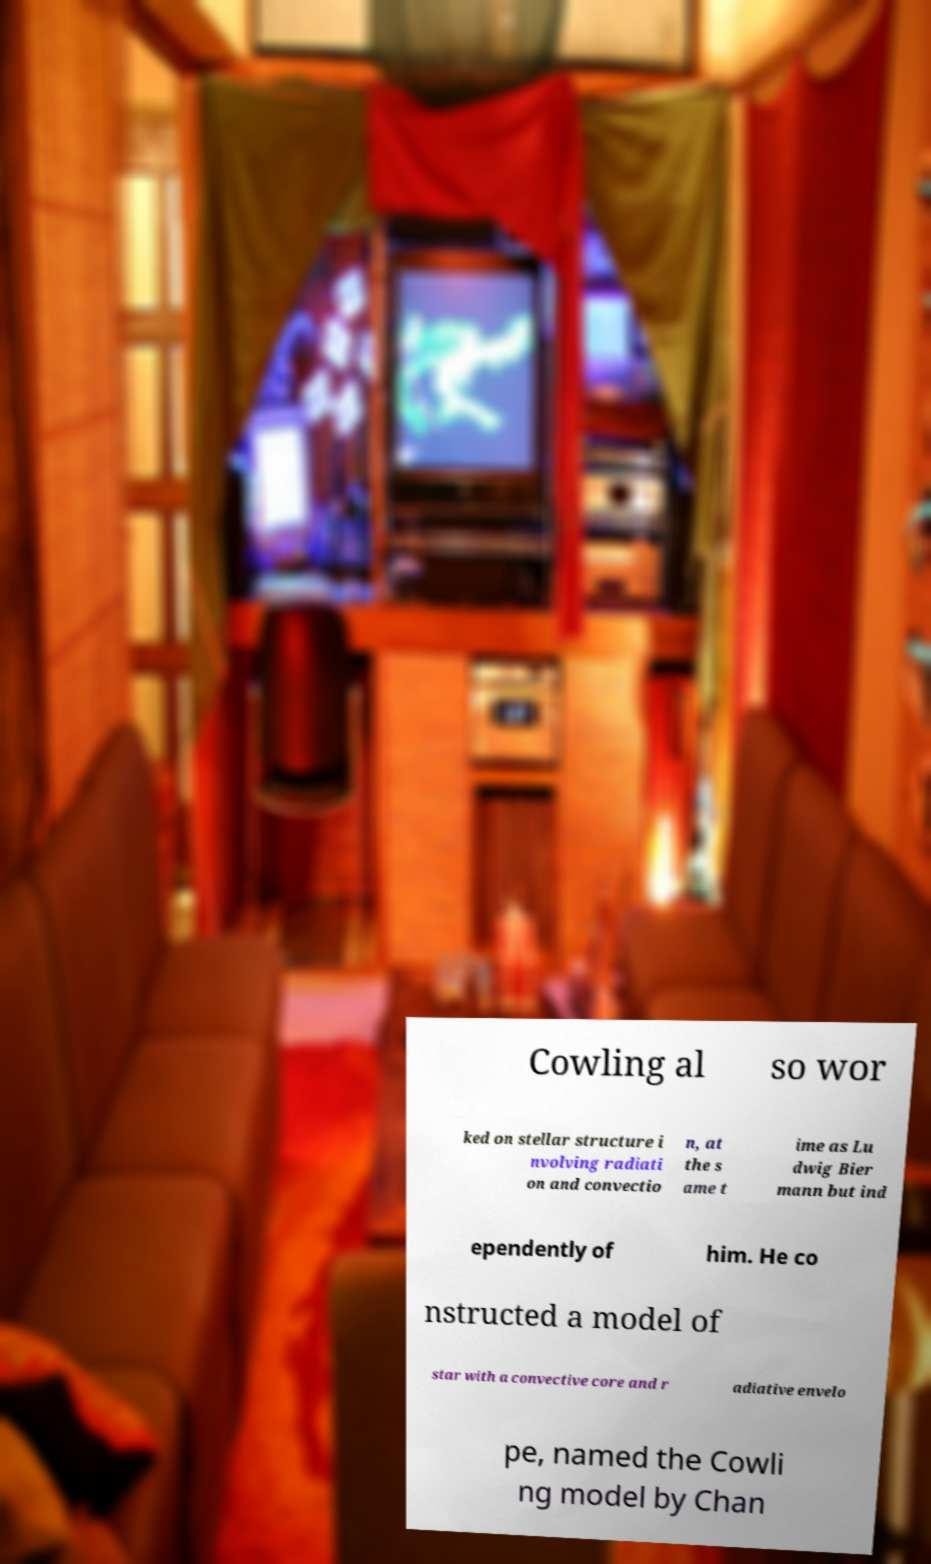Could you extract and type out the text from this image? Cowling al so wor ked on stellar structure i nvolving radiati on and convectio n, at the s ame t ime as Lu dwig Bier mann but ind ependently of him. He co nstructed a model of star with a convective core and r adiative envelo pe, named the Cowli ng model by Chan 